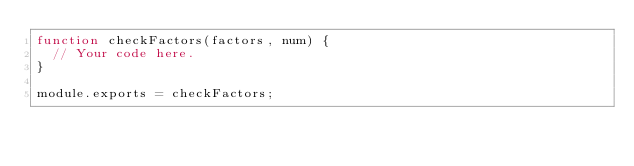<code> <loc_0><loc_0><loc_500><loc_500><_JavaScript_>function checkFactors(factors, num) {
  // Your code here.
}

module.exports = checkFactors;
</code> 